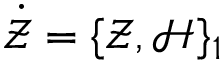<formula> <loc_0><loc_0><loc_500><loc_500>\dot { \mathcal { Z } } = \{ \mathcal { Z } , \mathcal { H } \} _ { 1 }</formula> 